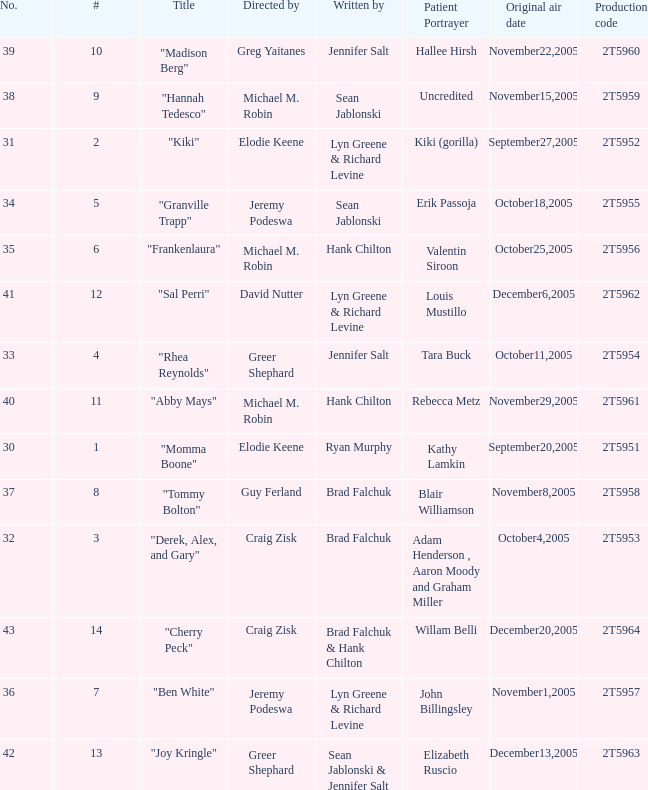What is the production code for the episode where the patient portrayer is Kathy Lamkin? 2T5951. 